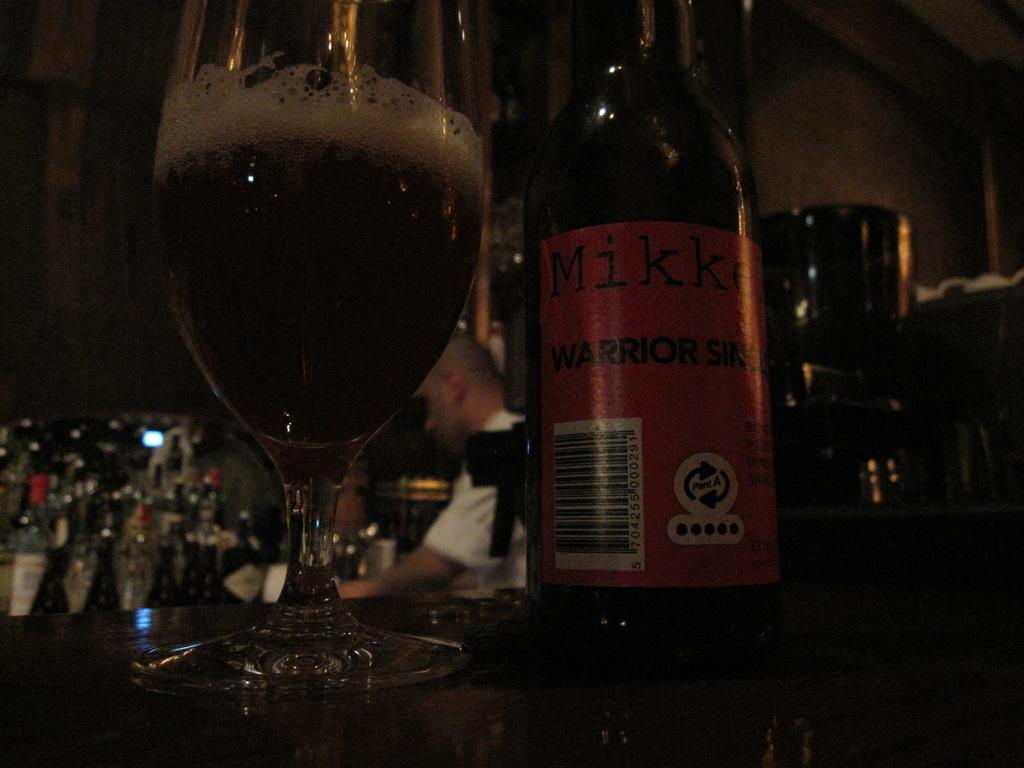In one or two sentences, can you explain what this image depicts? This picture shows few bottles and a glass with wine and a person standing. 